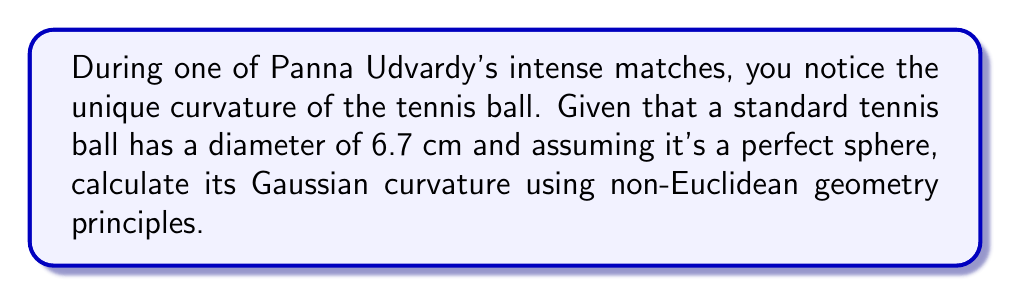Could you help me with this problem? To solve this problem, let's follow these steps:

1. Recall that for a sphere, the Gaussian curvature (K) is constant and given by:

   $$K = \frac{1}{R^2}$$

   where R is the radius of the sphere.

2. We're given the diameter of the tennis ball, so let's first calculate the radius:
   
   $$R = \frac{diameter}{2} = \frac{6.7\text{ cm}}{2} = 3.35\text{ cm}$$

3. Now, we can substitute this value into our Gaussian curvature formula:

   $$K = \frac{1}{(3.35\text{ cm})^2}$$

4. Simplify:
   
   $$K = \frac{1}{11.2225\text{ cm}^2} \approx 0.0891\text{ cm}^{-2}$$

5. It's important to note that in non-Euclidean geometry, particularly on a sphere, the sum of the angles in a triangle exceeds 180°. The excess is proportional to the area of the triangle and the Gaussian curvature. This property is fundamental in understanding how the geometry of the tennis ball's surface differs from a flat plane.

[asy]
import geometry;

size(200);
draw(circle((0,0),1));
dot((0,0), L="Center");
draw((0,0)--(1,0), arrow=Arrow(TeXHead), L="R");
label("Tennis ball surface", (0.7,0.7));
[/asy]

This diagram illustrates the cross-section of the tennis ball, emphasizing its spherical nature and constant radius, which leads to its uniform Gaussian curvature.
Answer: $0.0891\text{ cm}^{-2}$ 